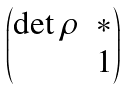<formula> <loc_0><loc_0><loc_500><loc_500>\begin{pmatrix} \det \rho & * \\ & 1 \end{pmatrix}</formula> 